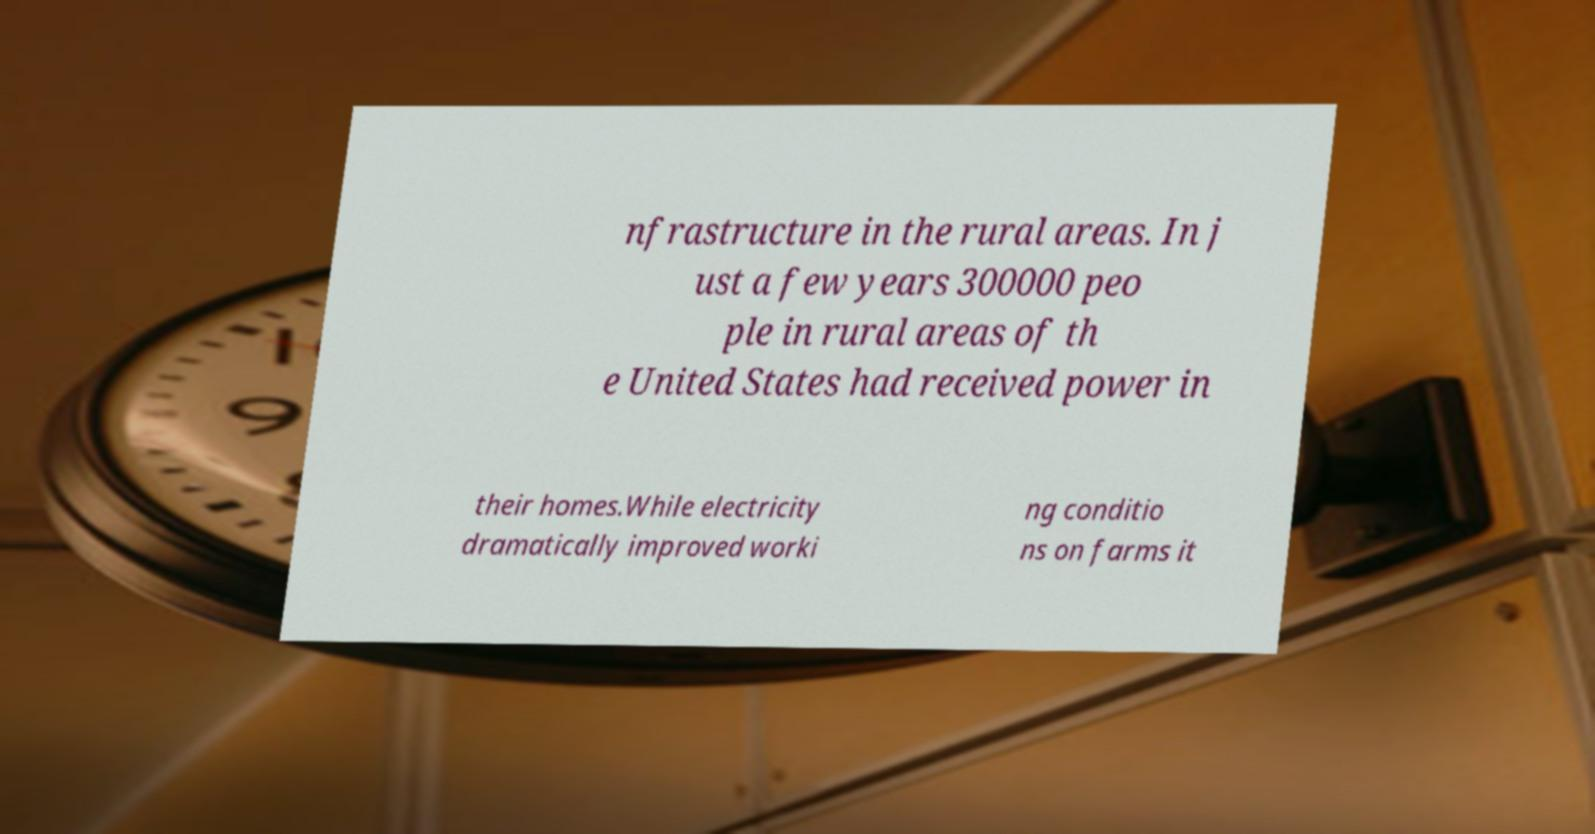What messages or text are displayed in this image? I need them in a readable, typed format. nfrastructure in the rural areas. In j ust a few years 300000 peo ple in rural areas of th e United States had received power in their homes.While electricity dramatically improved worki ng conditio ns on farms it 